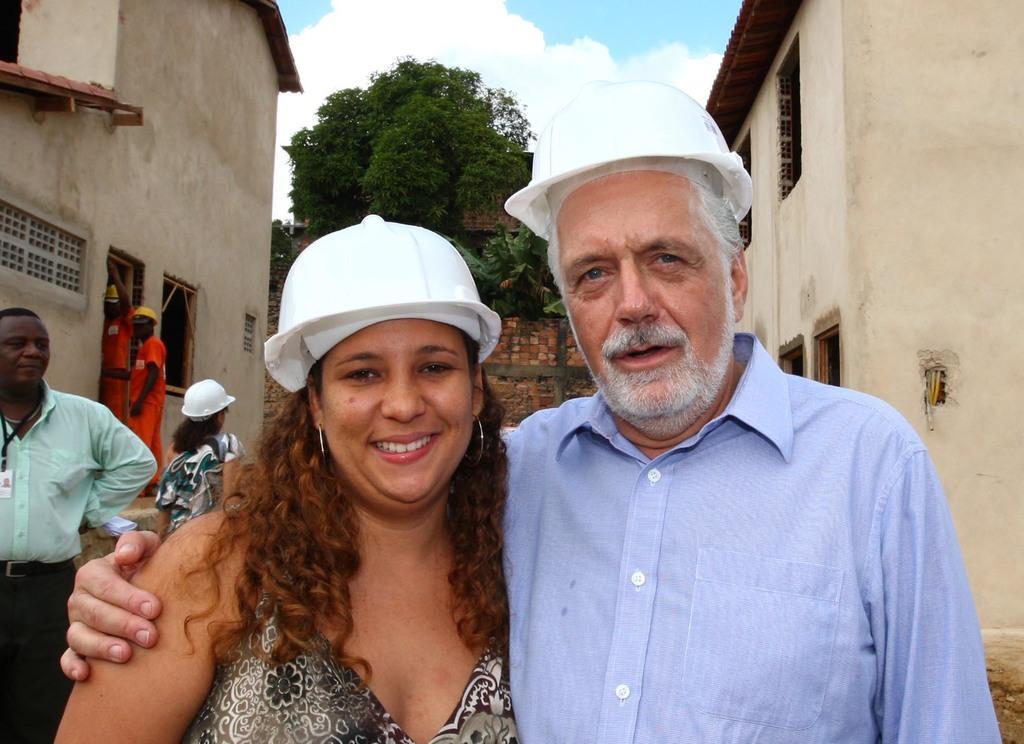In one or two sentences, can you explain what this image depicts? On the right side a man is standing, he wore a white color helmet. On the left side a woman is there, she wore dress and also smiling behind them there are trees. There are houses on either side of this image. 